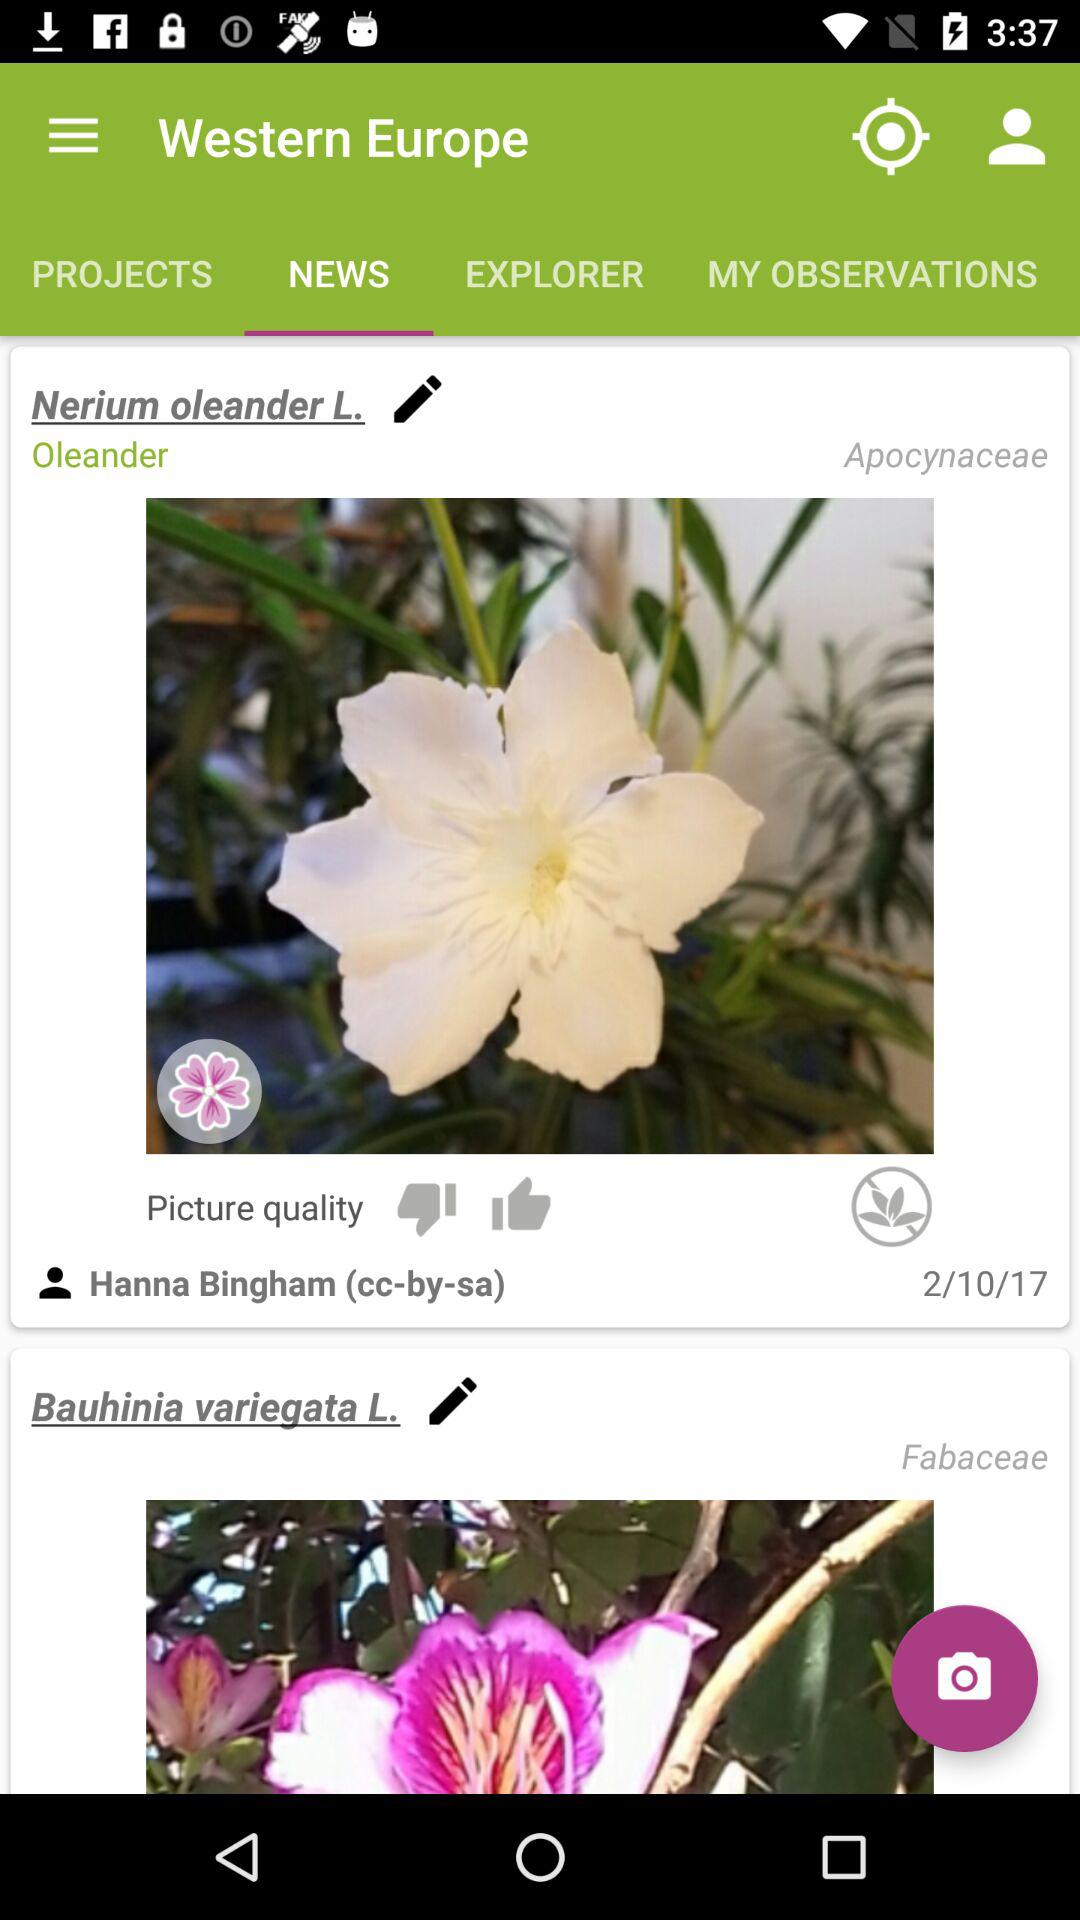Which family does Oleander belong to? Oleander belongs to the Apocynaceae family. 